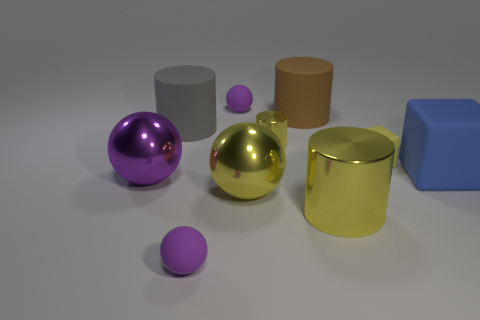Subtract all purple balls. How many were subtracted if there are1purple balls left? 2 Subtract all purple cubes. How many purple balls are left? 3 Subtract all cubes. How many objects are left? 8 Add 4 purple objects. How many purple objects exist? 7 Subtract 2 yellow cylinders. How many objects are left? 8 Subtract all small green metallic cylinders. Subtract all cubes. How many objects are left? 8 Add 5 tiny blocks. How many tiny blocks are left? 6 